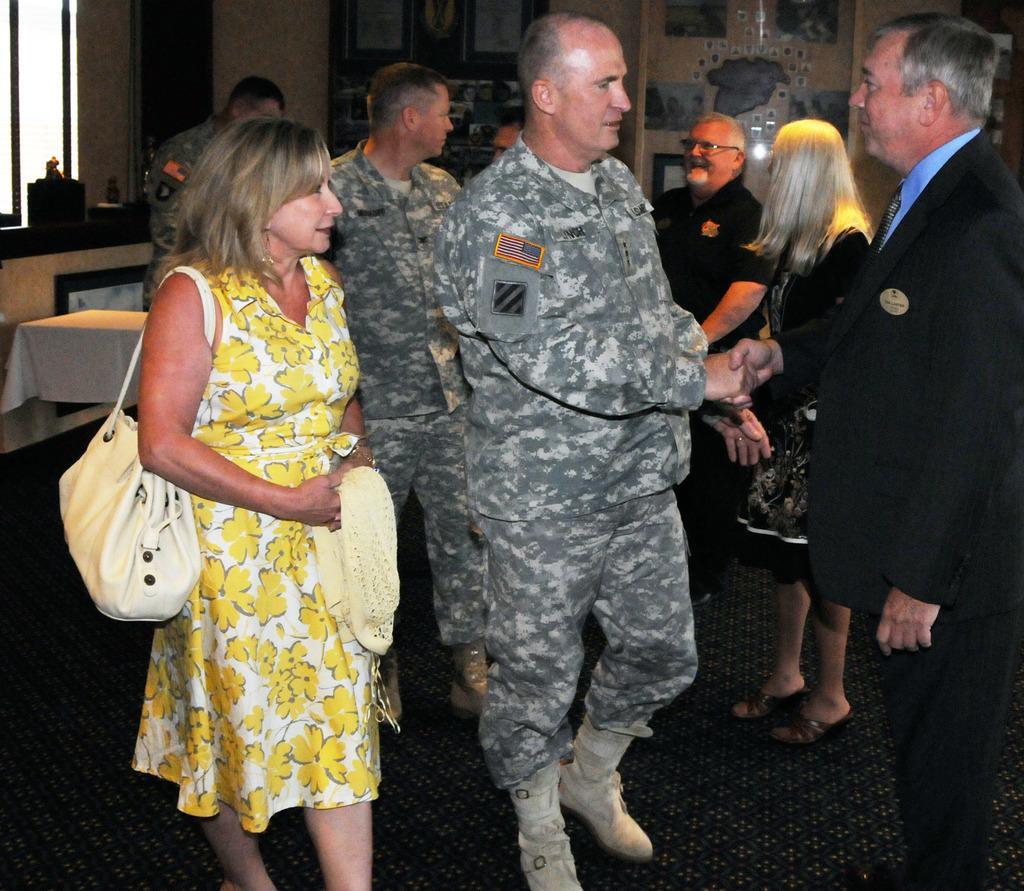Please provide a concise description of this image. In this image there are many people On the right there is a man he wear suit,tie, shirt and trouser. On the left there is a woman she wear handbag, dress her hair is short. In the background there are some people,table, window and wall. 